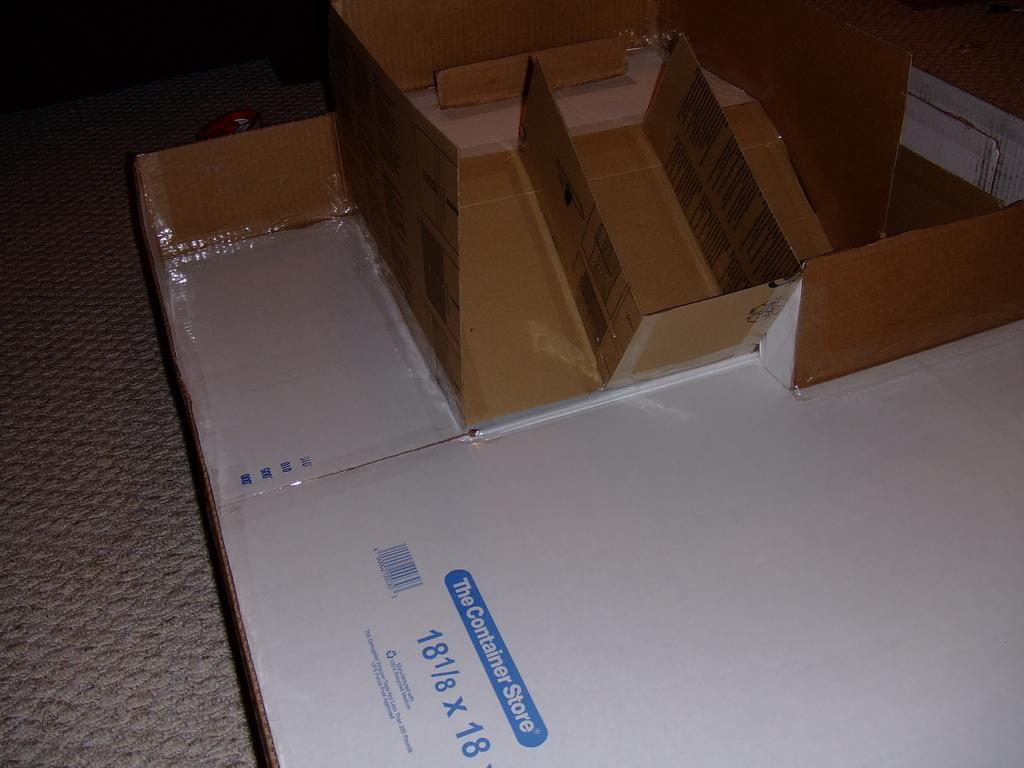<image>
Summarize the visual content of the image. A broken-down box labeled "The Container Store" is a base for other parts of boxes that are attached. 